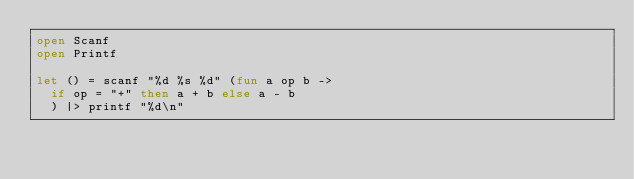Convert code to text. <code><loc_0><loc_0><loc_500><loc_500><_OCaml_>open Scanf
open Printf

let () = scanf "%d %s %d" (fun a op b ->
  if op = "+" then a + b else a - b
  ) |> printf "%d\n"</code> 